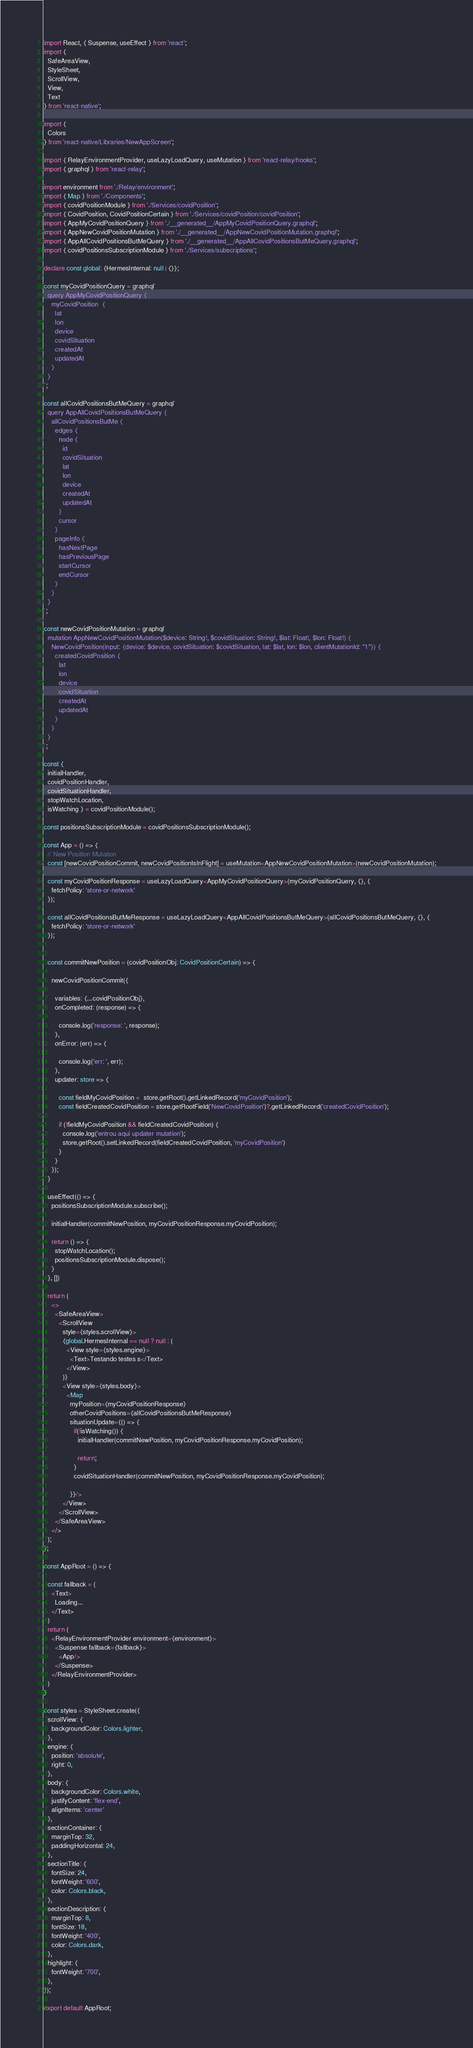Convert code to text. <code><loc_0><loc_0><loc_500><loc_500><_TypeScript_>import React, { Suspense, useEffect } from 'react';
import {
  SafeAreaView,
  StyleSheet,
  ScrollView,
  View,
  Text
} from 'react-native';

import {
  Colors
} from 'react-native/Libraries/NewAppScreen';

import { RelayEnvironmentProvider, useLazyLoadQuery, useMutation } from 'react-relay/hooks';
import { graphql } from 'react-relay';

import environment from './Relay/environment';
import { Map } from './Components';
import { covidPositionModule } from './Services/covidPosition';
import { CovidPosition, CovidPositionCertain } from './Services/covidPosition/covidPosition';
import { AppMyCovidPositionQuery } from './__generated__/AppMyCovidPositionQuery.graphql';
import { AppNewCovidPositionMutation } from './__generated__/AppNewCovidPositionMutation.graphql';
import { AppAllCovidPositionsButMeQuery } from './__generated__/AppAllCovidPositionsButMeQuery.graphql';
import { covidPositionsSubscriptionModule } from './Services/subscriptions';

declare const global: {HermesInternal: null | {}};

const myCovidPositionQuery = graphql`
  query AppMyCovidPositionQuery {
    myCovidPosition  {
      lat
      lon
      device
      covidSituation
      createdAt
      updatedAt
    }
  }
`;

const allCovidPositionsButMeQuery = graphql`
  query AppAllCovidPositionsButMeQuery {
    allCovidPositionsButMe {
      edges {
        node {
          id
          covidSituation
          lat
          lon
          device
          createdAt
          updatedAt
        }
        cursor
      }
      pageInfo {
        hasNextPage
        hasPreviousPage
        startCursor
        endCursor
      }
    }
  }
`;

const newCovidPositionMutation = graphql`
  mutation AppNewCovidPositionMutation($device: String!, $covidSituation: String!, $lat: Float!, $lon: Float!) {
    NewCovidPosition(input: {device: $device, covidSituation: $covidSituation, lat: $lat, lon: $lon, clientMutationId: "1"}) {
      createdCovidPosition {
        lat
        lon
        device
        covidSituation
        createdAt
        updatedAt
      }
    }
  }
`;

const {
  initialHandler,
  covidPositionHandler,
  covidSituationHandler,
  stopWatchLocation,
  isWatching } = covidPositionModule();

const positionsSubscriptionModule = covidPositionsSubscriptionModule();

const App = () => {
  // New Position Mutation
  const [newCovidPositionCommit, newCovidPositionIsInFlight] = useMutation<AppNewCovidPositionMutation>(newCovidPositionMutation);

  const myCovidPositionResponse = useLazyLoadQuery<AppMyCovidPositionQuery>(myCovidPositionQuery, {}, {
    fetchPolicy: 'store-or-network'
  });

  const allCovidPositionsButMeResponse = useLazyLoadQuery<AppAllCovidPositionsButMeQuery>(allCovidPositionsButMeQuery, {}, {
    fetchPolicy: 'store-or-network'
  });
  

  const commitNewPosition = (covidPositionObj: CovidPositionCertain) => {

    newCovidPositionCommit({
  
      variables: {...covidPositionObj},
      onCompleted: (response) => {

        console.log('response: ', response);
      },
      onError: (err) => {
        
        console.log('err: ', err);
      },
      updater: store => {

        const fieldMyCovidPosition =  store.getRoot().getLinkedRecord('myCovidPosition');
        const fieldCreatedCovidPosition = store.getRootField('NewCovidPosition')?.getLinkedRecord('createdCovidPosition');
        
        if (!fieldMyCovidPosition && fieldCreatedCovidPosition) {
          console.log('entrou aqui updater mutation');
          store.getRoot().setLinkedRecord(fieldCreatedCovidPosition, 'myCovidPosition')
        }
      }
    });
  }

  useEffect(() => {
    positionsSubscriptionModule.subscribe();

    initialHandler(commitNewPosition, myCovidPositionResponse.myCovidPosition);

    return () => {
      stopWatchLocation();
      positionsSubscriptionModule.dispose();
    }
  }, [])

  return (
    <>
      <SafeAreaView>
        <ScrollView
          style={styles.scrollView}>
          {global.HermesInternal == null ? null : (
            <View style={styles.engine}>
              <Text>Testando testes s</Text>
            </View>
          )}
          <View style={styles.body}>
            <Map
              myPosition={myCovidPositionResponse}
              otherCovidPositions={allCovidPositionsButMeResponse}
              situationUpdate={() => {
                if(!isWatching()) {
                  initialHandler(commitNewPosition, myCovidPositionResponse.myCovidPosition);

                  return;
                }
                covidSituationHandler(commitNewPosition, myCovidPositionResponse.myCovidPosition);

              }}/>
          </View>
        </ScrollView>
      </SafeAreaView>
    </>
  );
};

const AppRoot = () => {

  const fallback = (
    <Text>
      Loading...
    </Text>
  )
  return (
    <RelayEnvironmentProvider environment={environment}>
      <Suspense fallback={fallback}>
        <App/>
      </Suspense>
    </RelayEnvironmentProvider>
  )
}

const styles = StyleSheet.create({
  scrollView: {
    backgroundColor: Colors.lighter,
  },
  engine: {
    position: 'absolute',
    right: 0,
  },
  body: {
    backgroundColor: Colors.white,
    justifyContent: 'flex-end',
    alignItems: 'center'
  },
  sectionContainer: {
    marginTop: 32,
    paddingHorizontal: 24,
  },
  sectionTitle: {
    fontSize: 24,
    fontWeight: '600',
    color: Colors.black,
  },
  sectionDescription: {
    marginTop: 8,
    fontSize: 18,
    fontWeight: '400',
    color: Colors.dark,
  },
  highlight: {
    fontWeight: '700',
  },
});

export default AppRoot;
</code> 